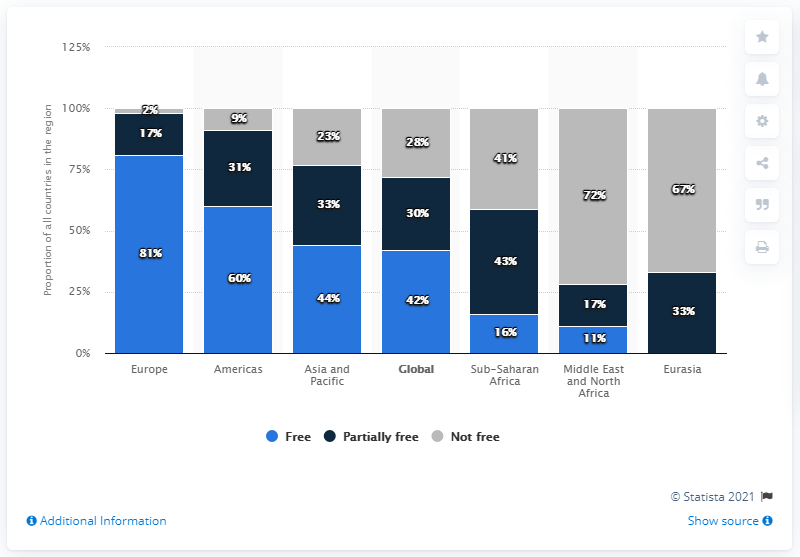List a handful of essential elements in this visual. The maximum value of navy blue bars across all regions is 43. In 2021, it was announced that Europe was considered the most free country in the world. The difference in the highest degree of freedom in Europe and the lowest degree of freedom in global is 53. 